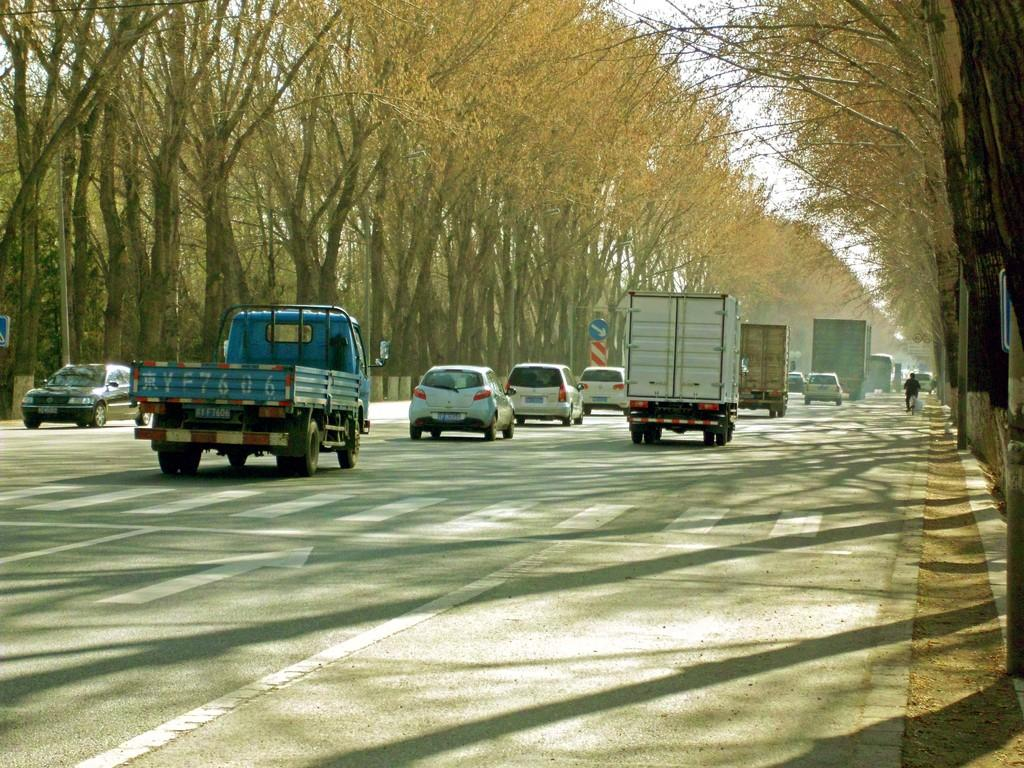What is the main feature of the image? There is a road in the image. What can be seen on the road? There are vehicles on the road. What type of vegetation is present near the road? There are trees beside the road. What part of the natural environment is visible in the image? The sky is partially visible above the trees. What type of feast is being held in the park shown in the image? There is no park or feast present in the image; it features a road with vehicles and trees. How many trees are visible in the tree shown in the image? There is no single tree shown in the image; it features multiple trees beside the road. 